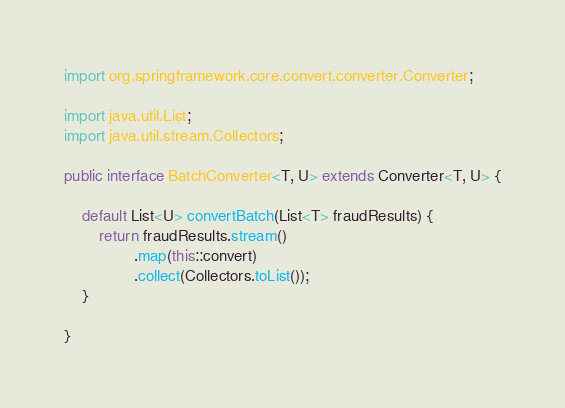<code> <loc_0><loc_0><loc_500><loc_500><_Java_>import org.springframework.core.convert.converter.Converter;

import java.util.List;
import java.util.stream.Collectors;

public interface BatchConverter<T, U> extends Converter<T, U> {

    default List<U> convertBatch(List<T> fraudResults) {
        return fraudResults.stream()
                .map(this::convert)
                .collect(Collectors.toList());
    }

}
</code> 